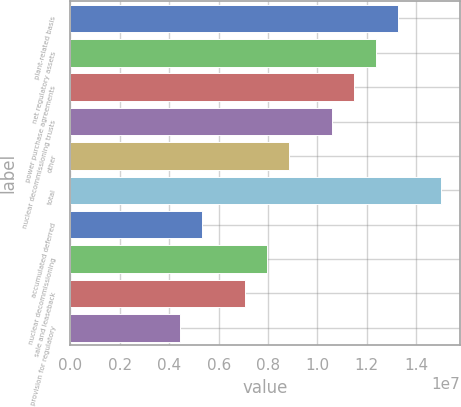Convert chart. <chart><loc_0><loc_0><loc_500><loc_500><bar_chart><fcel>plant-related basis<fcel>net regulatory assets<fcel>power purchase agreements<fcel>nuclear decommissioning trusts<fcel>other<fcel>total<fcel>accumulated deferred<fcel>nuclear decommissioning<fcel>sale and leaseback<fcel>provision for regulatory<nl><fcel>1.32561e+07<fcel>1.23733e+07<fcel>1.14904e+07<fcel>1.06075e+07<fcel>8.84179e+06<fcel>1.50219e+07<fcel>5.3103e+06<fcel>7.95892e+06<fcel>7.07604e+06<fcel>4.42743e+06<nl></chart> 